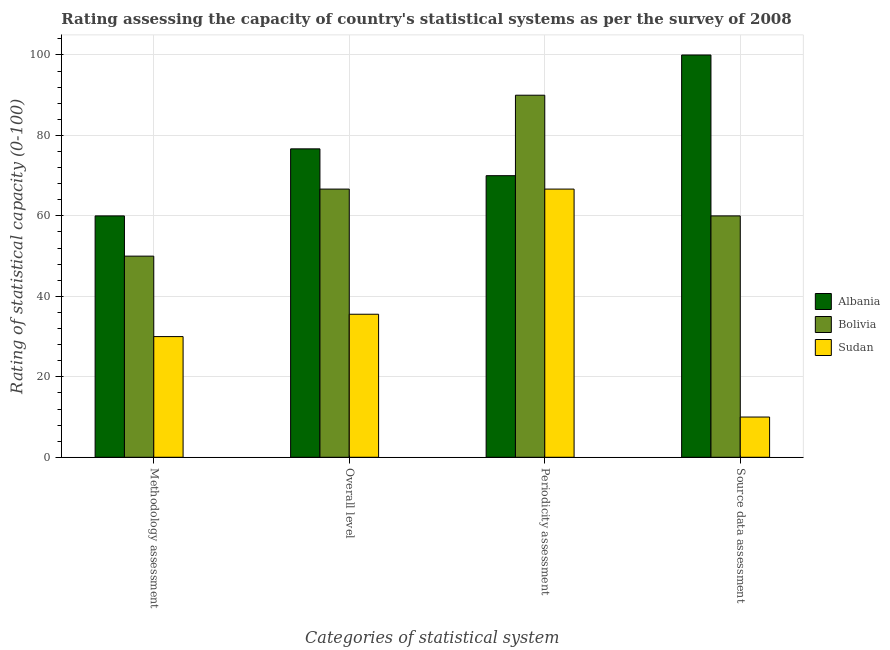How many different coloured bars are there?
Offer a terse response. 3. How many groups of bars are there?
Make the answer very short. 4. Are the number of bars per tick equal to the number of legend labels?
Provide a short and direct response. Yes. What is the label of the 4th group of bars from the left?
Provide a short and direct response. Source data assessment. What is the overall level rating in Sudan?
Provide a succinct answer. 35.56. Across all countries, what is the maximum overall level rating?
Keep it short and to the point. 76.67. Across all countries, what is the minimum periodicity assessment rating?
Keep it short and to the point. 66.67. In which country was the methodology assessment rating maximum?
Give a very brief answer. Albania. In which country was the periodicity assessment rating minimum?
Make the answer very short. Sudan. What is the total source data assessment rating in the graph?
Make the answer very short. 170. What is the difference between the methodology assessment rating in Bolivia and that in Albania?
Make the answer very short. -10. What is the difference between the periodicity assessment rating in Bolivia and the overall level rating in Albania?
Give a very brief answer. 13.33. What is the average methodology assessment rating per country?
Give a very brief answer. 46.67. What is the difference between the overall level rating and methodology assessment rating in Albania?
Keep it short and to the point. 16.67. In how many countries, is the overall level rating greater than 4 ?
Provide a succinct answer. 3. What is the ratio of the periodicity assessment rating in Bolivia to that in Albania?
Your answer should be very brief. 1.29. Is the overall level rating in Sudan less than that in Bolivia?
Your answer should be very brief. Yes. Is the difference between the source data assessment rating in Albania and Bolivia greater than the difference between the periodicity assessment rating in Albania and Bolivia?
Your answer should be very brief. Yes. What is the difference between the highest and the second highest source data assessment rating?
Your answer should be very brief. 40. In how many countries, is the source data assessment rating greater than the average source data assessment rating taken over all countries?
Ensure brevity in your answer.  2. Is the sum of the periodicity assessment rating in Albania and Bolivia greater than the maximum source data assessment rating across all countries?
Your answer should be very brief. Yes. What does the 3rd bar from the left in Overall level represents?
Your response must be concise. Sudan. What does the 2nd bar from the right in Overall level represents?
Keep it short and to the point. Bolivia. How many countries are there in the graph?
Your answer should be very brief. 3. What is the difference between two consecutive major ticks on the Y-axis?
Your answer should be compact. 20. Are the values on the major ticks of Y-axis written in scientific E-notation?
Offer a very short reply. No. Does the graph contain any zero values?
Your answer should be very brief. No. Does the graph contain grids?
Offer a terse response. Yes. Where does the legend appear in the graph?
Your response must be concise. Center right. How many legend labels are there?
Keep it short and to the point. 3. How are the legend labels stacked?
Your answer should be very brief. Vertical. What is the title of the graph?
Provide a short and direct response. Rating assessing the capacity of country's statistical systems as per the survey of 2008 . What is the label or title of the X-axis?
Make the answer very short. Categories of statistical system. What is the label or title of the Y-axis?
Make the answer very short. Rating of statistical capacity (0-100). What is the Rating of statistical capacity (0-100) of Albania in Methodology assessment?
Ensure brevity in your answer.  60. What is the Rating of statistical capacity (0-100) in Bolivia in Methodology assessment?
Offer a terse response. 50. What is the Rating of statistical capacity (0-100) of Albania in Overall level?
Make the answer very short. 76.67. What is the Rating of statistical capacity (0-100) of Bolivia in Overall level?
Provide a short and direct response. 66.67. What is the Rating of statistical capacity (0-100) in Sudan in Overall level?
Make the answer very short. 35.56. What is the Rating of statistical capacity (0-100) in Albania in Periodicity assessment?
Provide a succinct answer. 70. What is the Rating of statistical capacity (0-100) in Sudan in Periodicity assessment?
Provide a short and direct response. 66.67. What is the Rating of statistical capacity (0-100) of Albania in Source data assessment?
Provide a short and direct response. 100. What is the Rating of statistical capacity (0-100) in Sudan in Source data assessment?
Offer a very short reply. 10. Across all Categories of statistical system, what is the maximum Rating of statistical capacity (0-100) in Sudan?
Ensure brevity in your answer.  66.67. Across all Categories of statistical system, what is the minimum Rating of statistical capacity (0-100) in Sudan?
Ensure brevity in your answer.  10. What is the total Rating of statistical capacity (0-100) in Albania in the graph?
Your answer should be very brief. 306.67. What is the total Rating of statistical capacity (0-100) in Bolivia in the graph?
Your answer should be compact. 266.67. What is the total Rating of statistical capacity (0-100) in Sudan in the graph?
Offer a very short reply. 142.22. What is the difference between the Rating of statistical capacity (0-100) in Albania in Methodology assessment and that in Overall level?
Your answer should be very brief. -16.67. What is the difference between the Rating of statistical capacity (0-100) of Bolivia in Methodology assessment and that in Overall level?
Give a very brief answer. -16.67. What is the difference between the Rating of statistical capacity (0-100) of Sudan in Methodology assessment and that in Overall level?
Offer a very short reply. -5.56. What is the difference between the Rating of statistical capacity (0-100) of Bolivia in Methodology assessment and that in Periodicity assessment?
Offer a terse response. -40. What is the difference between the Rating of statistical capacity (0-100) in Sudan in Methodology assessment and that in Periodicity assessment?
Give a very brief answer. -36.67. What is the difference between the Rating of statistical capacity (0-100) in Bolivia in Methodology assessment and that in Source data assessment?
Offer a terse response. -10. What is the difference between the Rating of statistical capacity (0-100) of Albania in Overall level and that in Periodicity assessment?
Offer a terse response. 6.67. What is the difference between the Rating of statistical capacity (0-100) in Bolivia in Overall level and that in Periodicity assessment?
Offer a terse response. -23.33. What is the difference between the Rating of statistical capacity (0-100) in Sudan in Overall level and that in Periodicity assessment?
Provide a succinct answer. -31.11. What is the difference between the Rating of statistical capacity (0-100) of Albania in Overall level and that in Source data assessment?
Ensure brevity in your answer.  -23.33. What is the difference between the Rating of statistical capacity (0-100) in Sudan in Overall level and that in Source data assessment?
Ensure brevity in your answer.  25.56. What is the difference between the Rating of statistical capacity (0-100) of Albania in Periodicity assessment and that in Source data assessment?
Your answer should be compact. -30. What is the difference between the Rating of statistical capacity (0-100) of Sudan in Periodicity assessment and that in Source data assessment?
Keep it short and to the point. 56.67. What is the difference between the Rating of statistical capacity (0-100) of Albania in Methodology assessment and the Rating of statistical capacity (0-100) of Bolivia in Overall level?
Provide a short and direct response. -6.67. What is the difference between the Rating of statistical capacity (0-100) in Albania in Methodology assessment and the Rating of statistical capacity (0-100) in Sudan in Overall level?
Keep it short and to the point. 24.44. What is the difference between the Rating of statistical capacity (0-100) in Bolivia in Methodology assessment and the Rating of statistical capacity (0-100) in Sudan in Overall level?
Offer a very short reply. 14.44. What is the difference between the Rating of statistical capacity (0-100) in Albania in Methodology assessment and the Rating of statistical capacity (0-100) in Sudan in Periodicity assessment?
Offer a very short reply. -6.67. What is the difference between the Rating of statistical capacity (0-100) in Bolivia in Methodology assessment and the Rating of statistical capacity (0-100) in Sudan in Periodicity assessment?
Offer a very short reply. -16.67. What is the difference between the Rating of statistical capacity (0-100) of Albania in Methodology assessment and the Rating of statistical capacity (0-100) of Bolivia in Source data assessment?
Give a very brief answer. 0. What is the difference between the Rating of statistical capacity (0-100) in Albania in Overall level and the Rating of statistical capacity (0-100) in Bolivia in Periodicity assessment?
Ensure brevity in your answer.  -13.33. What is the difference between the Rating of statistical capacity (0-100) in Albania in Overall level and the Rating of statistical capacity (0-100) in Sudan in Periodicity assessment?
Your response must be concise. 10. What is the difference between the Rating of statistical capacity (0-100) of Albania in Overall level and the Rating of statistical capacity (0-100) of Bolivia in Source data assessment?
Offer a terse response. 16.67. What is the difference between the Rating of statistical capacity (0-100) of Albania in Overall level and the Rating of statistical capacity (0-100) of Sudan in Source data assessment?
Offer a terse response. 66.67. What is the difference between the Rating of statistical capacity (0-100) in Bolivia in Overall level and the Rating of statistical capacity (0-100) in Sudan in Source data assessment?
Your answer should be very brief. 56.67. What is the difference between the Rating of statistical capacity (0-100) in Albania in Periodicity assessment and the Rating of statistical capacity (0-100) in Bolivia in Source data assessment?
Ensure brevity in your answer.  10. What is the difference between the Rating of statistical capacity (0-100) in Albania in Periodicity assessment and the Rating of statistical capacity (0-100) in Sudan in Source data assessment?
Your answer should be very brief. 60. What is the difference between the Rating of statistical capacity (0-100) of Bolivia in Periodicity assessment and the Rating of statistical capacity (0-100) of Sudan in Source data assessment?
Your response must be concise. 80. What is the average Rating of statistical capacity (0-100) in Albania per Categories of statistical system?
Make the answer very short. 76.67. What is the average Rating of statistical capacity (0-100) of Bolivia per Categories of statistical system?
Offer a very short reply. 66.67. What is the average Rating of statistical capacity (0-100) in Sudan per Categories of statistical system?
Offer a very short reply. 35.56. What is the difference between the Rating of statistical capacity (0-100) of Albania and Rating of statistical capacity (0-100) of Bolivia in Methodology assessment?
Make the answer very short. 10. What is the difference between the Rating of statistical capacity (0-100) of Bolivia and Rating of statistical capacity (0-100) of Sudan in Methodology assessment?
Provide a short and direct response. 20. What is the difference between the Rating of statistical capacity (0-100) of Albania and Rating of statistical capacity (0-100) of Sudan in Overall level?
Give a very brief answer. 41.11. What is the difference between the Rating of statistical capacity (0-100) in Bolivia and Rating of statistical capacity (0-100) in Sudan in Overall level?
Your response must be concise. 31.11. What is the difference between the Rating of statistical capacity (0-100) in Bolivia and Rating of statistical capacity (0-100) in Sudan in Periodicity assessment?
Provide a short and direct response. 23.33. What is the difference between the Rating of statistical capacity (0-100) in Albania and Rating of statistical capacity (0-100) in Sudan in Source data assessment?
Your response must be concise. 90. What is the difference between the Rating of statistical capacity (0-100) in Bolivia and Rating of statistical capacity (0-100) in Sudan in Source data assessment?
Offer a terse response. 50. What is the ratio of the Rating of statistical capacity (0-100) of Albania in Methodology assessment to that in Overall level?
Provide a succinct answer. 0.78. What is the ratio of the Rating of statistical capacity (0-100) in Bolivia in Methodology assessment to that in Overall level?
Keep it short and to the point. 0.75. What is the ratio of the Rating of statistical capacity (0-100) of Sudan in Methodology assessment to that in Overall level?
Offer a very short reply. 0.84. What is the ratio of the Rating of statistical capacity (0-100) of Albania in Methodology assessment to that in Periodicity assessment?
Provide a short and direct response. 0.86. What is the ratio of the Rating of statistical capacity (0-100) in Bolivia in Methodology assessment to that in Periodicity assessment?
Offer a terse response. 0.56. What is the ratio of the Rating of statistical capacity (0-100) of Sudan in Methodology assessment to that in Periodicity assessment?
Ensure brevity in your answer.  0.45. What is the ratio of the Rating of statistical capacity (0-100) of Bolivia in Methodology assessment to that in Source data assessment?
Your response must be concise. 0.83. What is the ratio of the Rating of statistical capacity (0-100) of Sudan in Methodology assessment to that in Source data assessment?
Keep it short and to the point. 3. What is the ratio of the Rating of statistical capacity (0-100) of Albania in Overall level to that in Periodicity assessment?
Give a very brief answer. 1.1. What is the ratio of the Rating of statistical capacity (0-100) of Bolivia in Overall level to that in Periodicity assessment?
Give a very brief answer. 0.74. What is the ratio of the Rating of statistical capacity (0-100) of Sudan in Overall level to that in Periodicity assessment?
Make the answer very short. 0.53. What is the ratio of the Rating of statistical capacity (0-100) of Albania in Overall level to that in Source data assessment?
Your response must be concise. 0.77. What is the ratio of the Rating of statistical capacity (0-100) of Bolivia in Overall level to that in Source data assessment?
Offer a very short reply. 1.11. What is the ratio of the Rating of statistical capacity (0-100) of Sudan in Overall level to that in Source data assessment?
Provide a succinct answer. 3.56. What is the ratio of the Rating of statistical capacity (0-100) of Albania in Periodicity assessment to that in Source data assessment?
Your answer should be very brief. 0.7. What is the ratio of the Rating of statistical capacity (0-100) of Sudan in Periodicity assessment to that in Source data assessment?
Provide a short and direct response. 6.67. What is the difference between the highest and the second highest Rating of statistical capacity (0-100) of Albania?
Give a very brief answer. 23.33. What is the difference between the highest and the second highest Rating of statistical capacity (0-100) in Bolivia?
Your answer should be compact. 23.33. What is the difference between the highest and the second highest Rating of statistical capacity (0-100) of Sudan?
Your answer should be very brief. 31.11. What is the difference between the highest and the lowest Rating of statistical capacity (0-100) in Albania?
Your answer should be compact. 40. What is the difference between the highest and the lowest Rating of statistical capacity (0-100) in Sudan?
Provide a succinct answer. 56.67. 